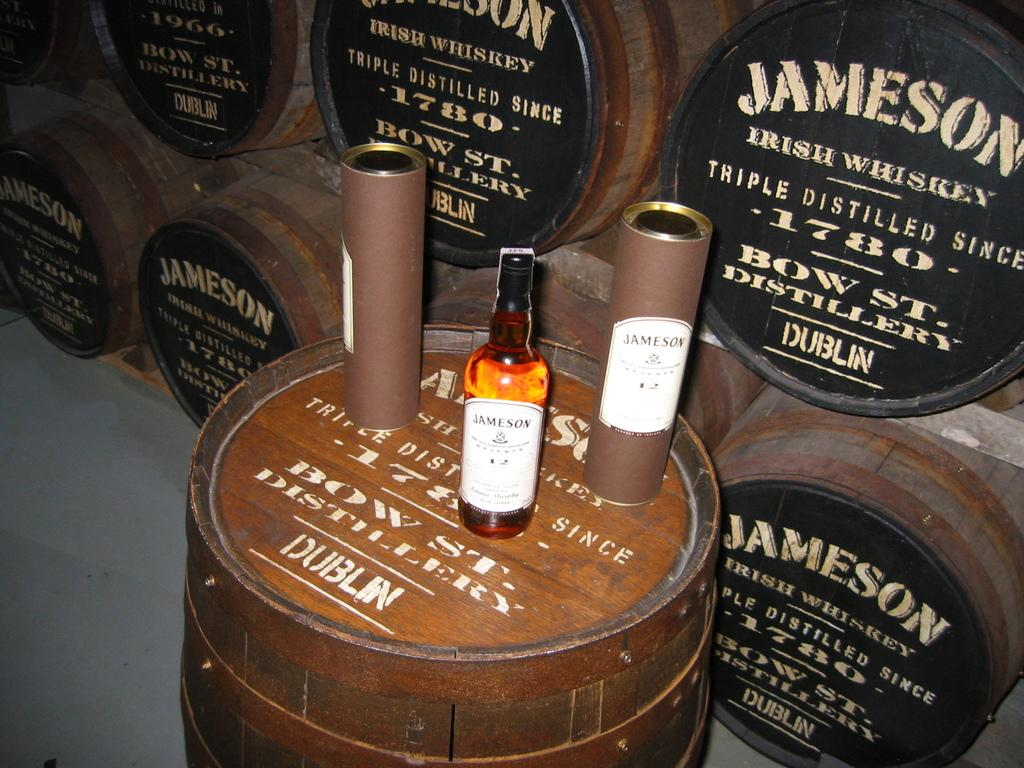What type of table is in the image? There is a wooden table in the image. What is placed on the wooden table? There is a bottle on the table. What can be seen on the bottle? There is text written on the bottle. What musical instruments are in the image? There are drums in the image. How are the drums arranged in the image? The drums are grouped together. Where are the drums located in relation to the bottle? The drums are kept beside the bottle. What type of crib is visible in the image? There is no crib present in the image. What color is the orange in the image? There is no orange present in the image. 